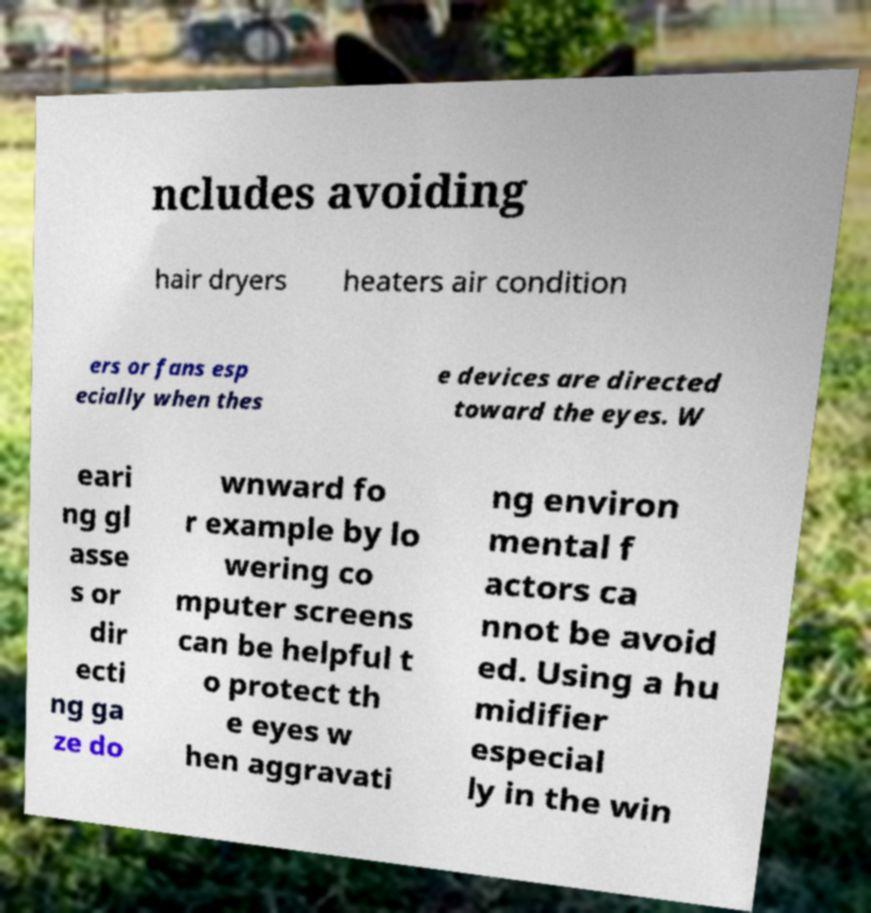There's text embedded in this image that I need extracted. Can you transcribe it verbatim? ncludes avoiding hair dryers heaters air condition ers or fans esp ecially when thes e devices are directed toward the eyes. W eari ng gl asse s or dir ecti ng ga ze do wnward fo r example by lo wering co mputer screens can be helpful t o protect th e eyes w hen aggravati ng environ mental f actors ca nnot be avoid ed. Using a hu midifier especial ly in the win 